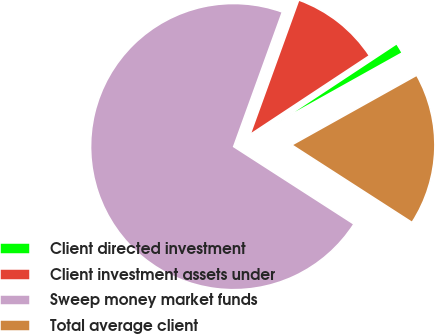<chart> <loc_0><loc_0><loc_500><loc_500><pie_chart><fcel>Client directed investment<fcel>Client investment assets under<fcel>Sweep money market funds<fcel>Total average client<nl><fcel>1.19%<fcel>10.18%<fcel>71.42%<fcel>17.21%<nl></chart> 